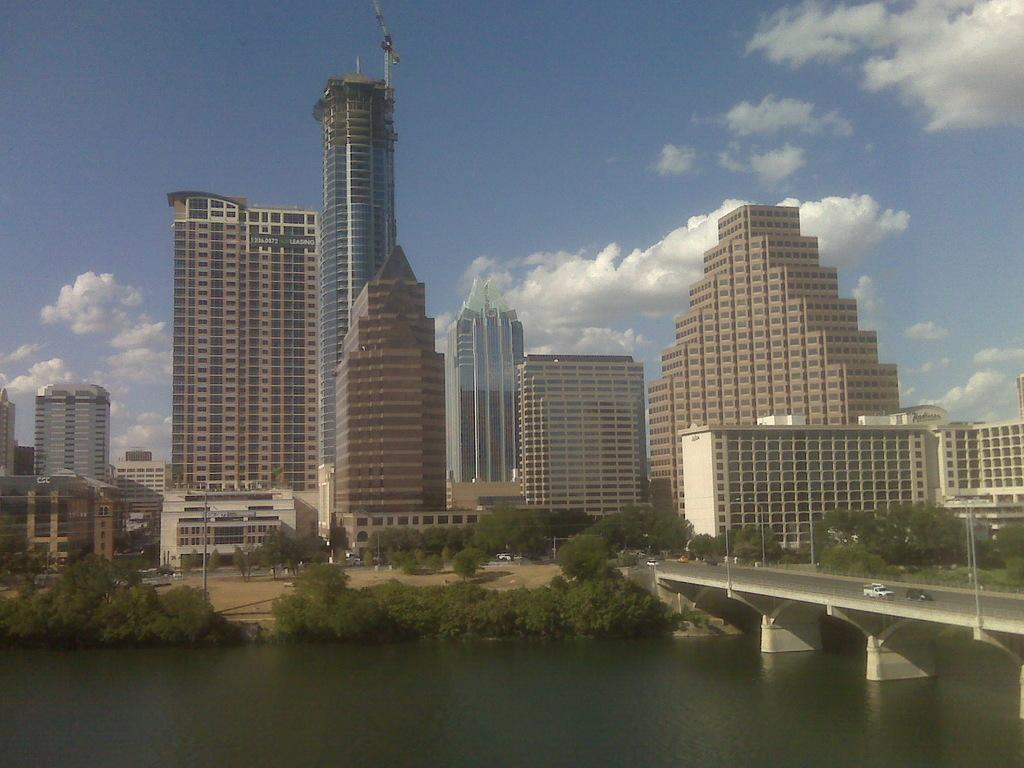What type of structures can be seen in the image? There is a group of buildings in the image. What is the purpose of the signboard in the image? The purpose of the signboard in the image is not clear from the facts provided. What are the poles used for in the image? The purpose of the poles in the image is not clear from the facts provided. What type of vegetation is present in the image? There is a group of trees in the image. What are the vehicles doing in the image? The vehicles are on a bridge in the image. What is the water body in the image? The water body in the image is not described in detail. What is the weather like in the image? The sky is visible in the image and appears cloudy. How many fans are visible in the image? There is no mention of fans in the image, so it is impossible to determine the number. What type of geese can be seen swimming in the water body in the image? There is no mention of geese in the image, so it is impossible to determine if any are present. 